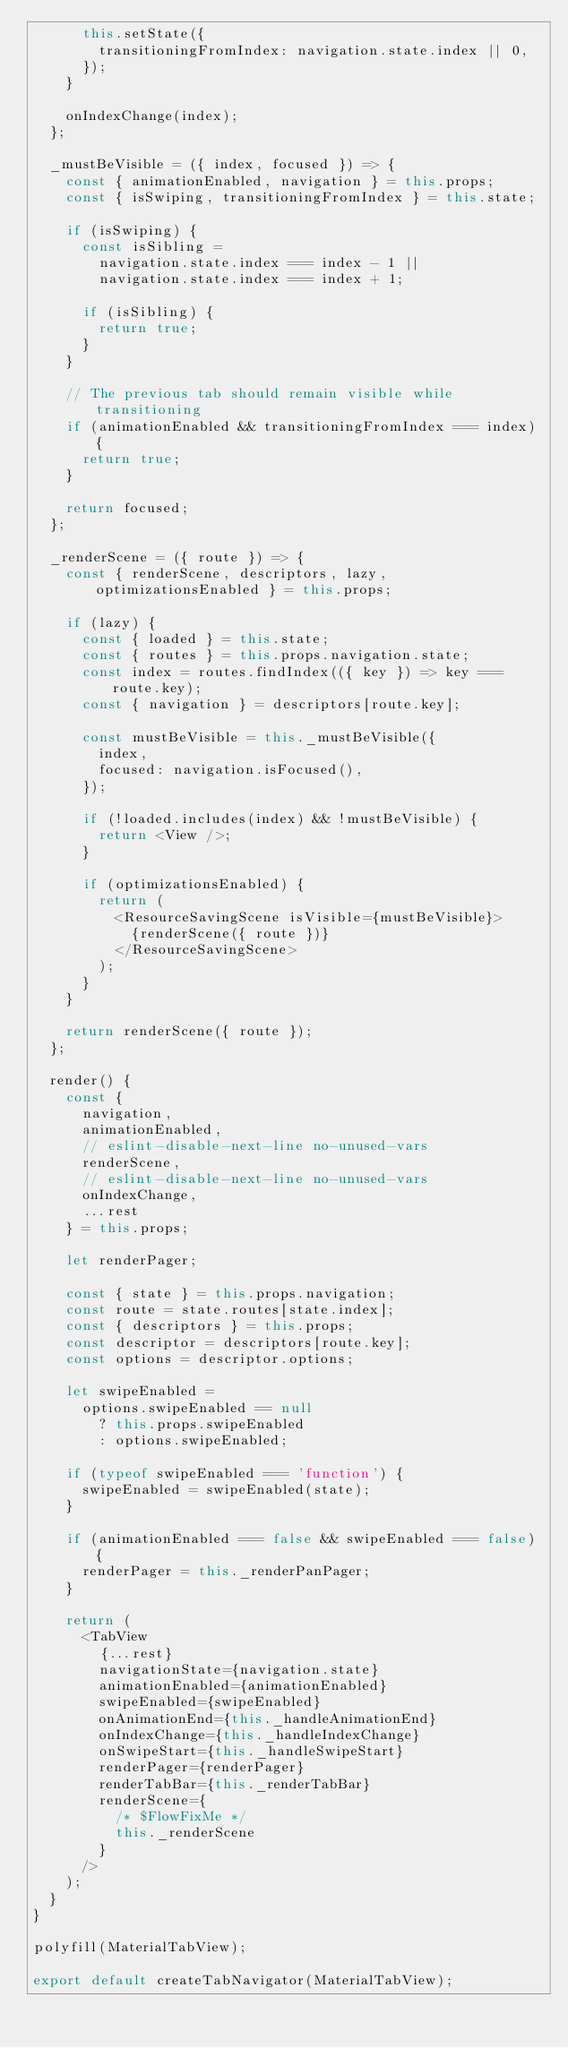Convert code to text. <code><loc_0><loc_0><loc_500><loc_500><_JavaScript_>      this.setState({
        transitioningFromIndex: navigation.state.index || 0,
      });
    }

    onIndexChange(index);
  };

  _mustBeVisible = ({ index, focused }) => {
    const { animationEnabled, navigation } = this.props;
    const { isSwiping, transitioningFromIndex } = this.state;

    if (isSwiping) {
      const isSibling =
        navigation.state.index === index - 1 ||
        navigation.state.index === index + 1;

      if (isSibling) {
        return true;
      }
    }

    // The previous tab should remain visible while transitioning
    if (animationEnabled && transitioningFromIndex === index) {
      return true;
    }

    return focused;
  };

  _renderScene = ({ route }) => {
    const { renderScene, descriptors, lazy, optimizationsEnabled } = this.props;

    if (lazy) {
      const { loaded } = this.state;
      const { routes } = this.props.navigation.state;
      const index = routes.findIndex(({ key }) => key === route.key);
      const { navigation } = descriptors[route.key];

      const mustBeVisible = this._mustBeVisible({
        index,
        focused: navigation.isFocused(),
      });

      if (!loaded.includes(index) && !mustBeVisible) {
        return <View />;
      }

      if (optimizationsEnabled) {
        return (
          <ResourceSavingScene isVisible={mustBeVisible}>
            {renderScene({ route })}
          </ResourceSavingScene>
        );
      }
    }

    return renderScene({ route });
  };

  render() {
    const {
      navigation,
      animationEnabled,
      // eslint-disable-next-line no-unused-vars
      renderScene,
      // eslint-disable-next-line no-unused-vars
      onIndexChange,
      ...rest
    } = this.props;

    let renderPager;

    const { state } = this.props.navigation;
    const route = state.routes[state.index];
    const { descriptors } = this.props;
    const descriptor = descriptors[route.key];
    const options = descriptor.options;

    let swipeEnabled =
      options.swipeEnabled == null
        ? this.props.swipeEnabled
        : options.swipeEnabled;

    if (typeof swipeEnabled === 'function') {
      swipeEnabled = swipeEnabled(state);
    }

    if (animationEnabled === false && swipeEnabled === false) {
      renderPager = this._renderPanPager;
    }

    return (
      <TabView
        {...rest}
        navigationState={navigation.state}
        animationEnabled={animationEnabled}
        swipeEnabled={swipeEnabled}
        onAnimationEnd={this._handleAnimationEnd}
        onIndexChange={this._handleIndexChange}
        onSwipeStart={this._handleSwipeStart}
        renderPager={renderPager}
        renderTabBar={this._renderTabBar}
        renderScene={
          /* $FlowFixMe */
          this._renderScene
        }
      />
    );
  }
}

polyfill(MaterialTabView);

export default createTabNavigator(MaterialTabView);
</code> 